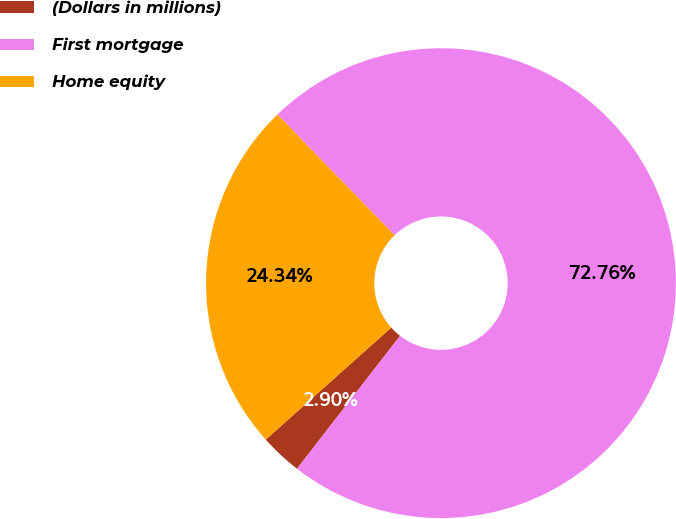<chart> <loc_0><loc_0><loc_500><loc_500><pie_chart><fcel>(Dollars in millions)<fcel>First mortgage<fcel>Home equity<nl><fcel>2.9%<fcel>72.76%<fcel>24.34%<nl></chart> 